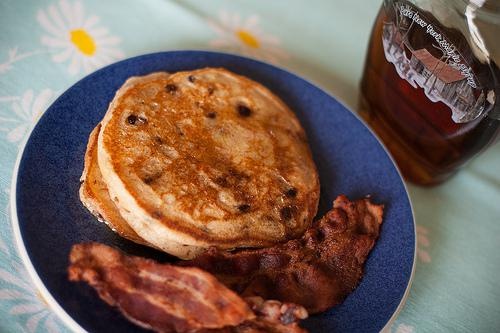Question: what design is on the table cloth?
Choices:
A. Squares.
B. Daisies.
C. Chevron.
D. Wagon wheels.
Answer with the letter. Answer: B Question: where is the plate?
Choices:
A. In dishwasher.
B. On the shelf.
C. On the table.
D. In the man's hands.
Answer with the letter. Answer: C 